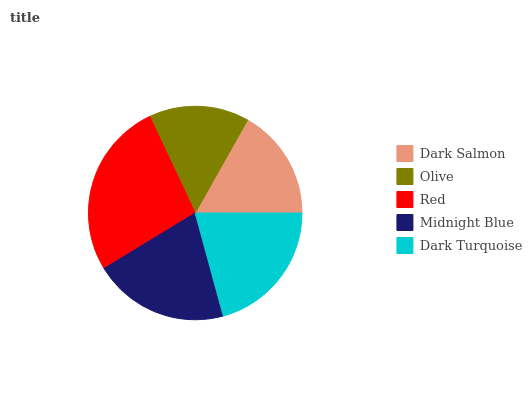Is Olive the minimum?
Answer yes or no. Yes. Is Red the maximum?
Answer yes or no. Yes. Is Red the minimum?
Answer yes or no. No. Is Olive the maximum?
Answer yes or no. No. Is Red greater than Olive?
Answer yes or no. Yes. Is Olive less than Red?
Answer yes or no. Yes. Is Olive greater than Red?
Answer yes or no. No. Is Red less than Olive?
Answer yes or no. No. Is Midnight Blue the high median?
Answer yes or no. Yes. Is Midnight Blue the low median?
Answer yes or no. Yes. Is Dark Turquoise the high median?
Answer yes or no. No. Is Dark Salmon the low median?
Answer yes or no. No. 